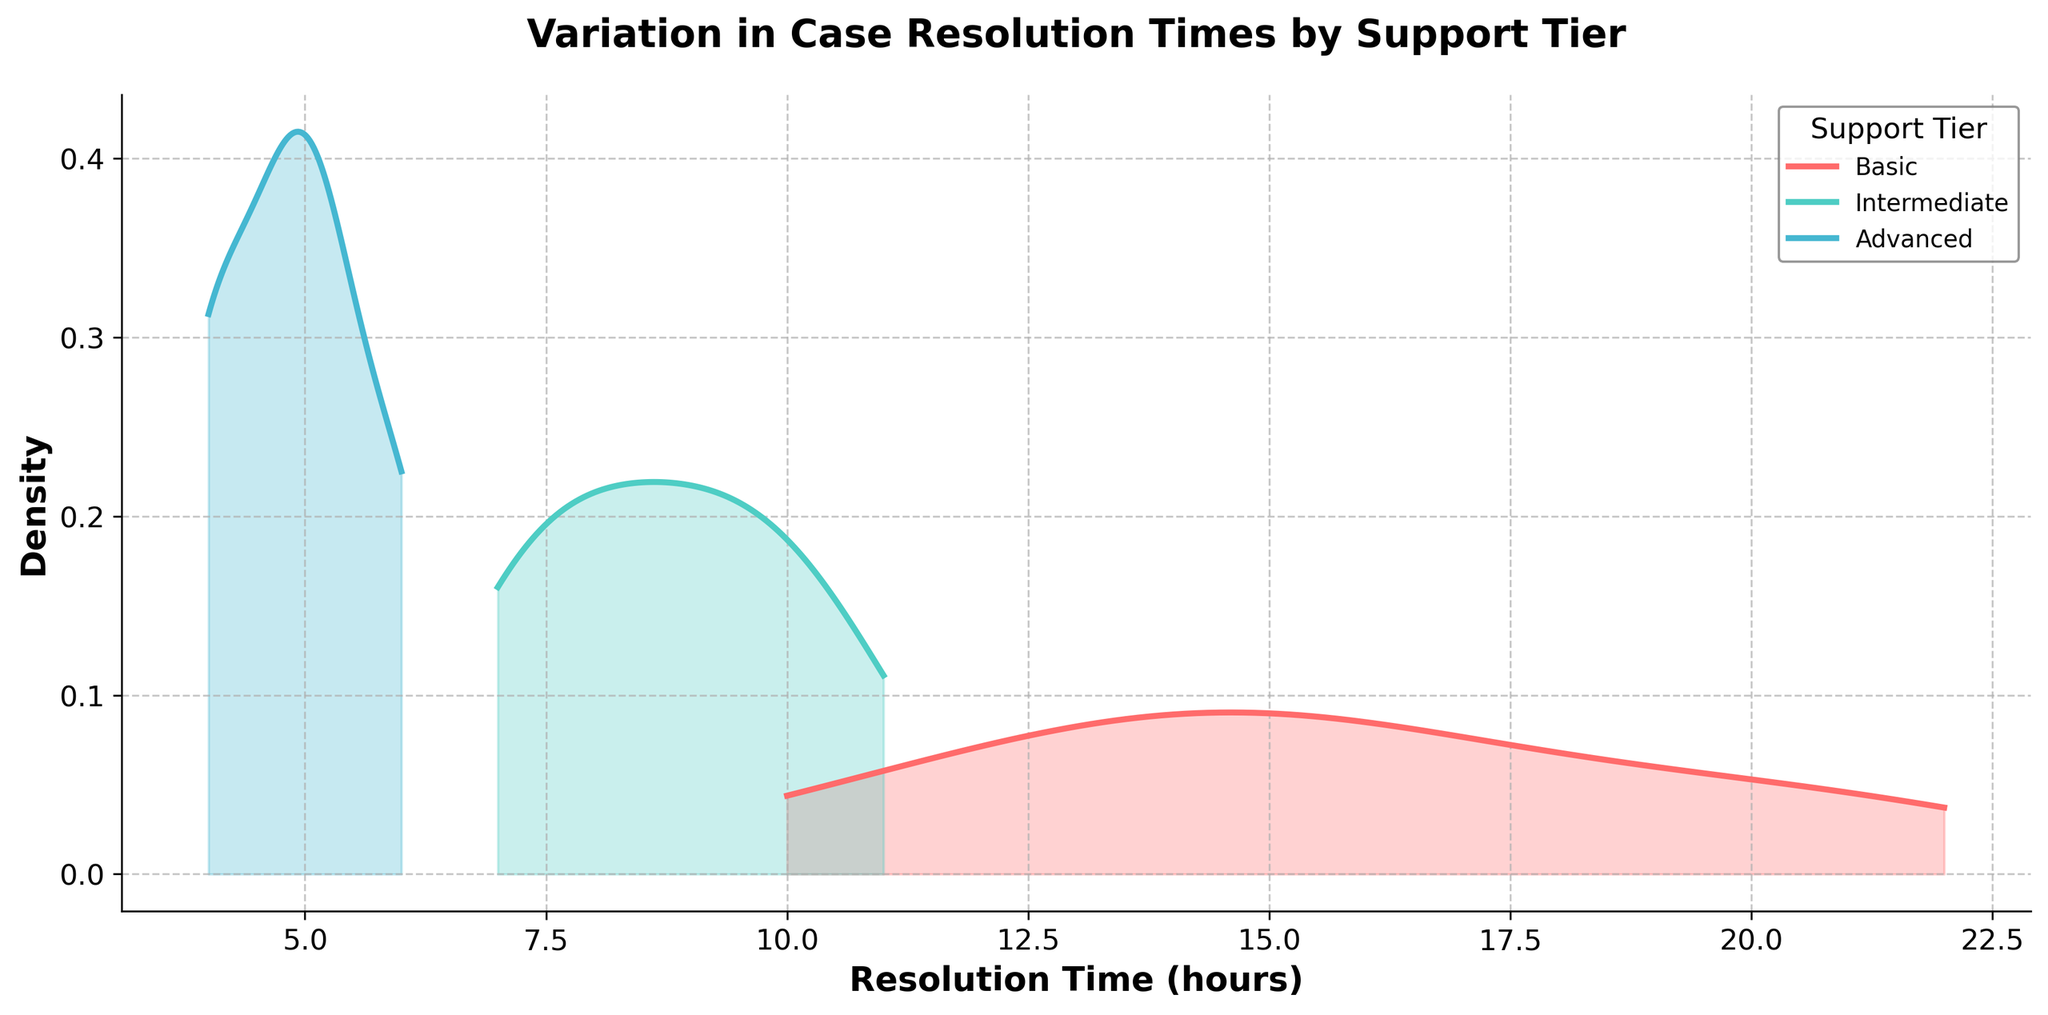What is the title of the plot? The title is located at the top of the plot and generally provides a summary of what the figure depicts. In this case, the title is "Variation in Case Resolution Times by Support Tier."
Answer: Variation in Case Resolution Times by Support Tier What does the x-axis represent? The x-axis generally represents the primary data dimension in a plot. Here, it represents "Resolution Time (hours)."
Answer: Resolution Time (hours) Which color represents the 'Advanced' support tier? In the plot, different colors distinguish each support tier. The 'Advanced' support tier is represented by the light blue color.
Answer: Light blue Which support tier has the widest range of resolution times? By observing the spread of the density curves along the x-axis, the 'Basic' support tier has the widest range of resolution times since its curve spans from around 10 to above 20 hours.
Answer: Basic Which support tier shows the highest density peak? Compare the peaks of the density curves. The 'Intermediate' support tier has the highest density peak among all tiers.
Answer: Intermediate How do the resolution times of the 'Intermediate' tier compare to the 'Advanced' tier? The 'Intermediate' tier has resolution times ranging from 7 to 11 hours, whereas the 'Advanced' tier has resolution times ranging from 4 to 6 hours. The 'Intermediate' range is generally higher.
Answer: Higher What is the approximate peak density value for the 'Basic' support tier? To determine this, locate the highest point on the density curve for the 'Basic' support tier on the y-axis. Its peak seems to be around 0.10 based on the plot.
Answer: ~0.10 How does the density of the 'Basic' support tier change across the x-axis? The density curve for the 'Basic' support tier starts around 10 hours, peaks between 14 and 18 hours, and then decreases gradually past 20 hours.
Answer: Peaks between 14 and 18 hours and decreases after 20 hours Is there any overlap in resolution times between the 'Intermediate' and 'Advanced' tiers? By observing where the curves overlap along the x-axis, we can see that both 'Intermediate' and 'Advanced' tiers overlap between 5 and 6 hours.
Answer: Yes Which tier has the least variation in resolution times? The 'Advanced' support tier shows the least variation in resolution times, as indicated by its narrowest and most concentrated density curve which ranges from 4 to 6 hours.
Answer: Advanced 